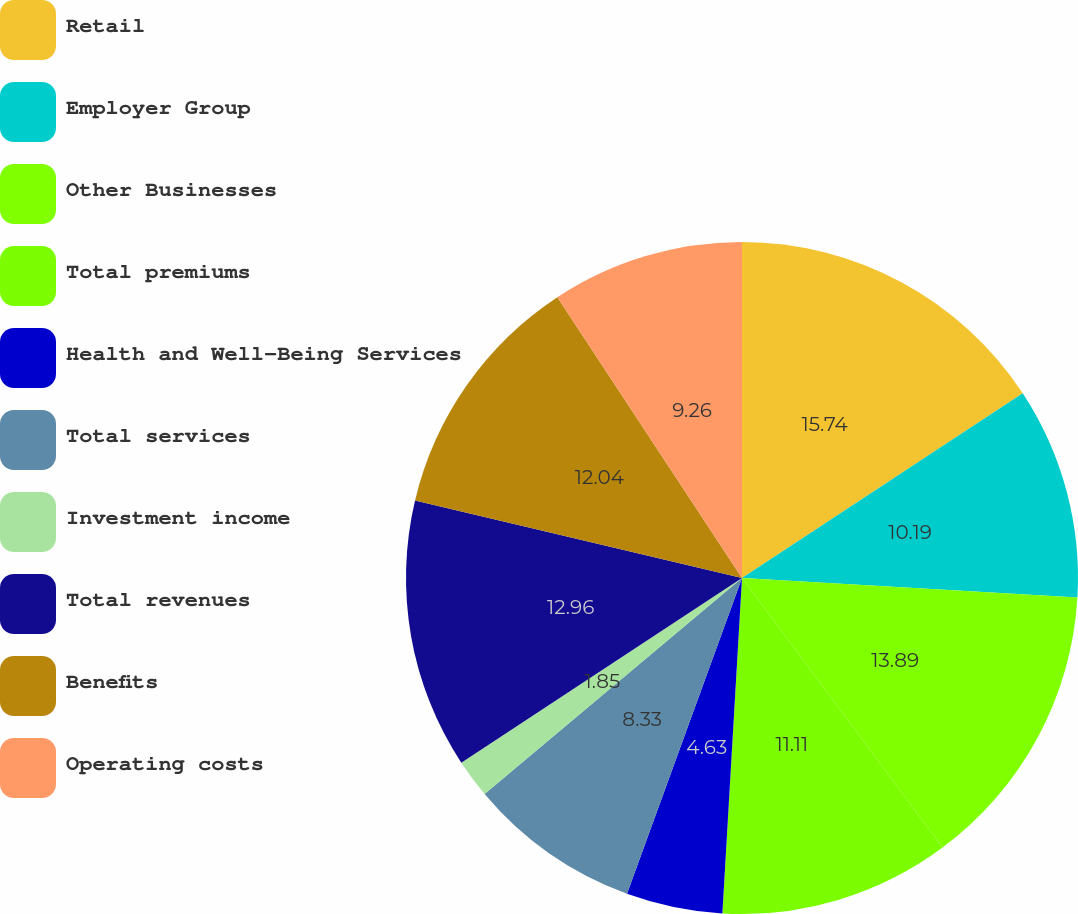Convert chart to OTSL. <chart><loc_0><loc_0><loc_500><loc_500><pie_chart><fcel>Retail<fcel>Employer Group<fcel>Other Businesses<fcel>Total premiums<fcel>Health and Well-Being Services<fcel>Total services<fcel>Investment income<fcel>Total revenues<fcel>Benefits<fcel>Operating costs<nl><fcel>15.74%<fcel>10.19%<fcel>13.89%<fcel>11.11%<fcel>4.63%<fcel>8.33%<fcel>1.85%<fcel>12.96%<fcel>12.04%<fcel>9.26%<nl></chart> 